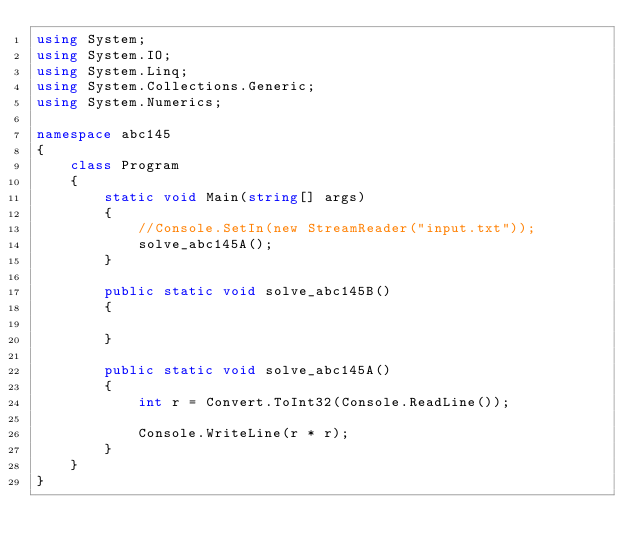Convert code to text. <code><loc_0><loc_0><loc_500><loc_500><_C#_>using System;
using System.IO;
using System.Linq;
using System.Collections.Generic;
using System.Numerics;

namespace abc145
{
    class Program
    {
        static void Main(string[] args)
        {
            //Console.SetIn(new StreamReader("input.txt"));
            solve_abc145A();
        }

        public static void solve_abc145B()
        {

        }

        public static void solve_abc145A()
        {
            int r = Convert.ToInt32(Console.ReadLine());

            Console.WriteLine(r * r);
        }
    }
}
</code> 